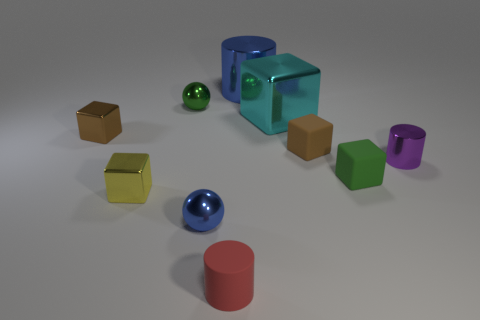Subtract all yellow metallic cubes. How many cubes are left? 4 Subtract all spheres. How many objects are left? 8 Subtract 1 cylinders. How many cylinders are left? 2 Subtract all brown cylinders. Subtract all brown spheres. How many cylinders are left? 3 Subtract all brown cubes. How many gray spheres are left? 0 Subtract all small matte spheres. Subtract all red matte cylinders. How many objects are left? 9 Add 5 tiny green shiny objects. How many tiny green shiny objects are left? 6 Add 8 spheres. How many spheres exist? 10 Subtract all cyan blocks. How many blocks are left? 4 Subtract 0 gray cylinders. How many objects are left? 10 